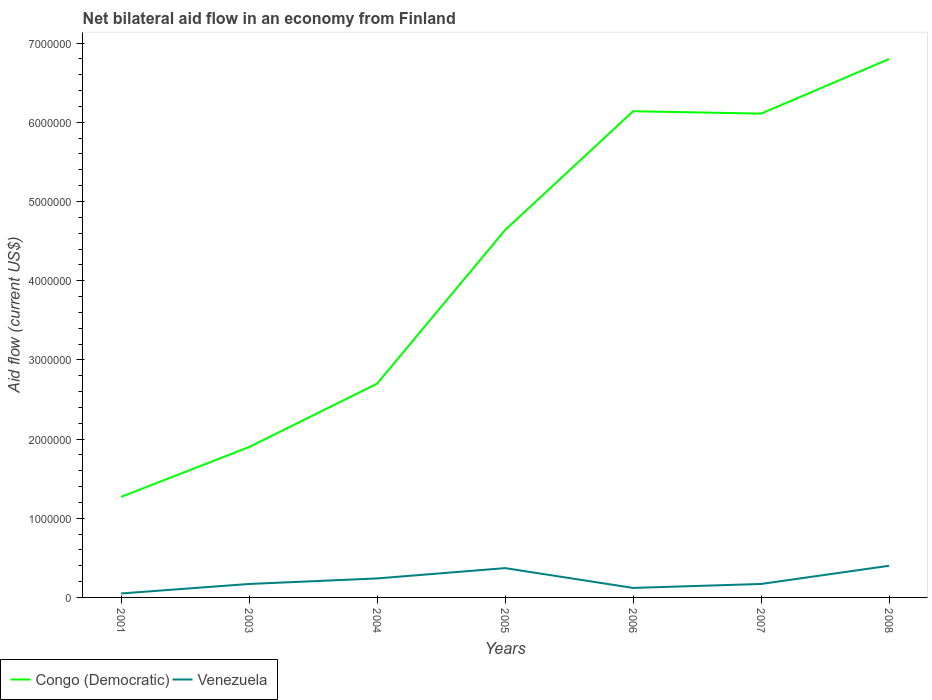Does the line corresponding to Venezuela intersect with the line corresponding to Congo (Democratic)?
Your answer should be compact. No. Across all years, what is the maximum net bilateral aid flow in Congo (Democratic)?
Your answer should be very brief. 1.27e+06. What is the total net bilateral aid flow in Congo (Democratic) in the graph?
Your answer should be compact. -6.90e+05. What is the difference between the highest and the lowest net bilateral aid flow in Congo (Democratic)?
Make the answer very short. 4. Are the values on the major ticks of Y-axis written in scientific E-notation?
Your answer should be compact. No. Does the graph contain grids?
Provide a short and direct response. No. Where does the legend appear in the graph?
Offer a very short reply. Bottom left. How are the legend labels stacked?
Offer a very short reply. Horizontal. What is the title of the graph?
Give a very brief answer. Net bilateral aid flow in an economy from Finland. What is the label or title of the Y-axis?
Offer a terse response. Aid flow (current US$). What is the Aid flow (current US$) in Congo (Democratic) in 2001?
Make the answer very short. 1.27e+06. What is the Aid flow (current US$) in Congo (Democratic) in 2003?
Offer a terse response. 1.90e+06. What is the Aid flow (current US$) in Venezuela in 2003?
Provide a short and direct response. 1.70e+05. What is the Aid flow (current US$) of Congo (Democratic) in 2004?
Your answer should be very brief. 2.70e+06. What is the Aid flow (current US$) in Congo (Democratic) in 2005?
Your response must be concise. 4.64e+06. What is the Aid flow (current US$) of Venezuela in 2005?
Ensure brevity in your answer.  3.70e+05. What is the Aid flow (current US$) in Congo (Democratic) in 2006?
Give a very brief answer. 6.14e+06. What is the Aid flow (current US$) of Venezuela in 2006?
Ensure brevity in your answer.  1.20e+05. What is the Aid flow (current US$) in Congo (Democratic) in 2007?
Give a very brief answer. 6.11e+06. What is the Aid flow (current US$) in Venezuela in 2007?
Give a very brief answer. 1.70e+05. What is the Aid flow (current US$) of Congo (Democratic) in 2008?
Offer a terse response. 6.80e+06. What is the Aid flow (current US$) in Venezuela in 2008?
Give a very brief answer. 4.00e+05. Across all years, what is the maximum Aid flow (current US$) of Congo (Democratic)?
Offer a very short reply. 6.80e+06. Across all years, what is the minimum Aid flow (current US$) in Congo (Democratic)?
Your response must be concise. 1.27e+06. Across all years, what is the minimum Aid flow (current US$) in Venezuela?
Provide a succinct answer. 5.00e+04. What is the total Aid flow (current US$) of Congo (Democratic) in the graph?
Ensure brevity in your answer.  2.96e+07. What is the total Aid flow (current US$) in Venezuela in the graph?
Ensure brevity in your answer.  1.52e+06. What is the difference between the Aid flow (current US$) in Congo (Democratic) in 2001 and that in 2003?
Provide a short and direct response. -6.30e+05. What is the difference between the Aid flow (current US$) of Venezuela in 2001 and that in 2003?
Ensure brevity in your answer.  -1.20e+05. What is the difference between the Aid flow (current US$) in Congo (Democratic) in 2001 and that in 2004?
Provide a succinct answer. -1.43e+06. What is the difference between the Aid flow (current US$) of Venezuela in 2001 and that in 2004?
Offer a terse response. -1.90e+05. What is the difference between the Aid flow (current US$) in Congo (Democratic) in 2001 and that in 2005?
Keep it short and to the point. -3.37e+06. What is the difference between the Aid flow (current US$) of Venezuela in 2001 and that in 2005?
Make the answer very short. -3.20e+05. What is the difference between the Aid flow (current US$) in Congo (Democratic) in 2001 and that in 2006?
Keep it short and to the point. -4.87e+06. What is the difference between the Aid flow (current US$) in Venezuela in 2001 and that in 2006?
Your answer should be compact. -7.00e+04. What is the difference between the Aid flow (current US$) of Congo (Democratic) in 2001 and that in 2007?
Your response must be concise. -4.84e+06. What is the difference between the Aid flow (current US$) of Venezuela in 2001 and that in 2007?
Offer a terse response. -1.20e+05. What is the difference between the Aid flow (current US$) in Congo (Democratic) in 2001 and that in 2008?
Your answer should be compact. -5.53e+06. What is the difference between the Aid flow (current US$) of Venezuela in 2001 and that in 2008?
Ensure brevity in your answer.  -3.50e+05. What is the difference between the Aid flow (current US$) in Congo (Democratic) in 2003 and that in 2004?
Your response must be concise. -8.00e+05. What is the difference between the Aid flow (current US$) in Congo (Democratic) in 2003 and that in 2005?
Your answer should be very brief. -2.74e+06. What is the difference between the Aid flow (current US$) of Venezuela in 2003 and that in 2005?
Your response must be concise. -2.00e+05. What is the difference between the Aid flow (current US$) of Congo (Democratic) in 2003 and that in 2006?
Ensure brevity in your answer.  -4.24e+06. What is the difference between the Aid flow (current US$) of Venezuela in 2003 and that in 2006?
Your answer should be compact. 5.00e+04. What is the difference between the Aid flow (current US$) of Congo (Democratic) in 2003 and that in 2007?
Keep it short and to the point. -4.21e+06. What is the difference between the Aid flow (current US$) in Congo (Democratic) in 2003 and that in 2008?
Provide a short and direct response. -4.90e+06. What is the difference between the Aid flow (current US$) in Venezuela in 2003 and that in 2008?
Make the answer very short. -2.30e+05. What is the difference between the Aid flow (current US$) in Congo (Democratic) in 2004 and that in 2005?
Offer a very short reply. -1.94e+06. What is the difference between the Aid flow (current US$) in Venezuela in 2004 and that in 2005?
Your response must be concise. -1.30e+05. What is the difference between the Aid flow (current US$) of Congo (Democratic) in 2004 and that in 2006?
Keep it short and to the point. -3.44e+06. What is the difference between the Aid flow (current US$) in Venezuela in 2004 and that in 2006?
Make the answer very short. 1.20e+05. What is the difference between the Aid flow (current US$) in Congo (Democratic) in 2004 and that in 2007?
Your response must be concise. -3.41e+06. What is the difference between the Aid flow (current US$) in Venezuela in 2004 and that in 2007?
Your answer should be very brief. 7.00e+04. What is the difference between the Aid flow (current US$) of Congo (Democratic) in 2004 and that in 2008?
Provide a short and direct response. -4.10e+06. What is the difference between the Aid flow (current US$) of Venezuela in 2004 and that in 2008?
Give a very brief answer. -1.60e+05. What is the difference between the Aid flow (current US$) in Congo (Democratic) in 2005 and that in 2006?
Provide a succinct answer. -1.50e+06. What is the difference between the Aid flow (current US$) of Venezuela in 2005 and that in 2006?
Make the answer very short. 2.50e+05. What is the difference between the Aid flow (current US$) in Congo (Democratic) in 2005 and that in 2007?
Provide a succinct answer. -1.47e+06. What is the difference between the Aid flow (current US$) of Congo (Democratic) in 2005 and that in 2008?
Provide a short and direct response. -2.16e+06. What is the difference between the Aid flow (current US$) of Venezuela in 2006 and that in 2007?
Make the answer very short. -5.00e+04. What is the difference between the Aid flow (current US$) of Congo (Democratic) in 2006 and that in 2008?
Provide a succinct answer. -6.60e+05. What is the difference between the Aid flow (current US$) of Venezuela in 2006 and that in 2008?
Keep it short and to the point. -2.80e+05. What is the difference between the Aid flow (current US$) in Congo (Democratic) in 2007 and that in 2008?
Provide a succinct answer. -6.90e+05. What is the difference between the Aid flow (current US$) of Venezuela in 2007 and that in 2008?
Provide a short and direct response. -2.30e+05. What is the difference between the Aid flow (current US$) of Congo (Democratic) in 2001 and the Aid flow (current US$) of Venezuela in 2003?
Your response must be concise. 1.10e+06. What is the difference between the Aid flow (current US$) of Congo (Democratic) in 2001 and the Aid flow (current US$) of Venezuela in 2004?
Offer a terse response. 1.03e+06. What is the difference between the Aid flow (current US$) in Congo (Democratic) in 2001 and the Aid flow (current US$) in Venezuela in 2006?
Your response must be concise. 1.15e+06. What is the difference between the Aid flow (current US$) of Congo (Democratic) in 2001 and the Aid flow (current US$) of Venezuela in 2007?
Keep it short and to the point. 1.10e+06. What is the difference between the Aid flow (current US$) of Congo (Democratic) in 2001 and the Aid flow (current US$) of Venezuela in 2008?
Your answer should be very brief. 8.70e+05. What is the difference between the Aid flow (current US$) of Congo (Democratic) in 2003 and the Aid flow (current US$) of Venezuela in 2004?
Your response must be concise. 1.66e+06. What is the difference between the Aid flow (current US$) of Congo (Democratic) in 2003 and the Aid flow (current US$) of Venezuela in 2005?
Provide a succinct answer. 1.53e+06. What is the difference between the Aid flow (current US$) in Congo (Democratic) in 2003 and the Aid flow (current US$) in Venezuela in 2006?
Offer a very short reply. 1.78e+06. What is the difference between the Aid flow (current US$) of Congo (Democratic) in 2003 and the Aid flow (current US$) of Venezuela in 2007?
Your response must be concise. 1.73e+06. What is the difference between the Aid flow (current US$) in Congo (Democratic) in 2003 and the Aid flow (current US$) in Venezuela in 2008?
Give a very brief answer. 1.50e+06. What is the difference between the Aid flow (current US$) in Congo (Democratic) in 2004 and the Aid flow (current US$) in Venezuela in 2005?
Your response must be concise. 2.33e+06. What is the difference between the Aid flow (current US$) of Congo (Democratic) in 2004 and the Aid flow (current US$) of Venezuela in 2006?
Make the answer very short. 2.58e+06. What is the difference between the Aid flow (current US$) in Congo (Democratic) in 2004 and the Aid flow (current US$) in Venezuela in 2007?
Provide a succinct answer. 2.53e+06. What is the difference between the Aid flow (current US$) in Congo (Democratic) in 2004 and the Aid flow (current US$) in Venezuela in 2008?
Offer a very short reply. 2.30e+06. What is the difference between the Aid flow (current US$) in Congo (Democratic) in 2005 and the Aid flow (current US$) in Venezuela in 2006?
Provide a succinct answer. 4.52e+06. What is the difference between the Aid flow (current US$) in Congo (Democratic) in 2005 and the Aid flow (current US$) in Venezuela in 2007?
Ensure brevity in your answer.  4.47e+06. What is the difference between the Aid flow (current US$) in Congo (Democratic) in 2005 and the Aid flow (current US$) in Venezuela in 2008?
Provide a short and direct response. 4.24e+06. What is the difference between the Aid flow (current US$) in Congo (Democratic) in 2006 and the Aid flow (current US$) in Venezuela in 2007?
Provide a short and direct response. 5.97e+06. What is the difference between the Aid flow (current US$) of Congo (Democratic) in 2006 and the Aid flow (current US$) of Venezuela in 2008?
Give a very brief answer. 5.74e+06. What is the difference between the Aid flow (current US$) in Congo (Democratic) in 2007 and the Aid flow (current US$) in Venezuela in 2008?
Provide a succinct answer. 5.71e+06. What is the average Aid flow (current US$) in Congo (Democratic) per year?
Offer a very short reply. 4.22e+06. What is the average Aid flow (current US$) in Venezuela per year?
Provide a short and direct response. 2.17e+05. In the year 2001, what is the difference between the Aid flow (current US$) of Congo (Democratic) and Aid flow (current US$) of Venezuela?
Keep it short and to the point. 1.22e+06. In the year 2003, what is the difference between the Aid flow (current US$) in Congo (Democratic) and Aid flow (current US$) in Venezuela?
Keep it short and to the point. 1.73e+06. In the year 2004, what is the difference between the Aid flow (current US$) of Congo (Democratic) and Aid flow (current US$) of Venezuela?
Your answer should be very brief. 2.46e+06. In the year 2005, what is the difference between the Aid flow (current US$) of Congo (Democratic) and Aid flow (current US$) of Venezuela?
Your answer should be very brief. 4.27e+06. In the year 2006, what is the difference between the Aid flow (current US$) in Congo (Democratic) and Aid flow (current US$) in Venezuela?
Your answer should be compact. 6.02e+06. In the year 2007, what is the difference between the Aid flow (current US$) of Congo (Democratic) and Aid flow (current US$) of Venezuela?
Your answer should be compact. 5.94e+06. In the year 2008, what is the difference between the Aid flow (current US$) in Congo (Democratic) and Aid flow (current US$) in Venezuela?
Give a very brief answer. 6.40e+06. What is the ratio of the Aid flow (current US$) in Congo (Democratic) in 2001 to that in 2003?
Your response must be concise. 0.67. What is the ratio of the Aid flow (current US$) in Venezuela in 2001 to that in 2003?
Your answer should be very brief. 0.29. What is the ratio of the Aid flow (current US$) of Congo (Democratic) in 2001 to that in 2004?
Give a very brief answer. 0.47. What is the ratio of the Aid flow (current US$) in Venezuela in 2001 to that in 2004?
Ensure brevity in your answer.  0.21. What is the ratio of the Aid flow (current US$) in Congo (Democratic) in 2001 to that in 2005?
Provide a succinct answer. 0.27. What is the ratio of the Aid flow (current US$) in Venezuela in 2001 to that in 2005?
Give a very brief answer. 0.14. What is the ratio of the Aid flow (current US$) in Congo (Democratic) in 2001 to that in 2006?
Your answer should be compact. 0.21. What is the ratio of the Aid flow (current US$) in Venezuela in 2001 to that in 2006?
Your response must be concise. 0.42. What is the ratio of the Aid flow (current US$) of Congo (Democratic) in 2001 to that in 2007?
Offer a terse response. 0.21. What is the ratio of the Aid flow (current US$) in Venezuela in 2001 to that in 2007?
Make the answer very short. 0.29. What is the ratio of the Aid flow (current US$) in Congo (Democratic) in 2001 to that in 2008?
Make the answer very short. 0.19. What is the ratio of the Aid flow (current US$) in Venezuela in 2001 to that in 2008?
Provide a short and direct response. 0.12. What is the ratio of the Aid flow (current US$) in Congo (Democratic) in 2003 to that in 2004?
Offer a terse response. 0.7. What is the ratio of the Aid flow (current US$) of Venezuela in 2003 to that in 2004?
Give a very brief answer. 0.71. What is the ratio of the Aid flow (current US$) of Congo (Democratic) in 2003 to that in 2005?
Keep it short and to the point. 0.41. What is the ratio of the Aid flow (current US$) in Venezuela in 2003 to that in 2005?
Make the answer very short. 0.46. What is the ratio of the Aid flow (current US$) of Congo (Democratic) in 2003 to that in 2006?
Offer a very short reply. 0.31. What is the ratio of the Aid flow (current US$) of Venezuela in 2003 to that in 2006?
Your response must be concise. 1.42. What is the ratio of the Aid flow (current US$) of Congo (Democratic) in 2003 to that in 2007?
Offer a terse response. 0.31. What is the ratio of the Aid flow (current US$) of Venezuela in 2003 to that in 2007?
Your response must be concise. 1. What is the ratio of the Aid flow (current US$) of Congo (Democratic) in 2003 to that in 2008?
Make the answer very short. 0.28. What is the ratio of the Aid flow (current US$) of Venezuela in 2003 to that in 2008?
Keep it short and to the point. 0.42. What is the ratio of the Aid flow (current US$) of Congo (Democratic) in 2004 to that in 2005?
Your answer should be very brief. 0.58. What is the ratio of the Aid flow (current US$) in Venezuela in 2004 to that in 2005?
Offer a very short reply. 0.65. What is the ratio of the Aid flow (current US$) of Congo (Democratic) in 2004 to that in 2006?
Provide a short and direct response. 0.44. What is the ratio of the Aid flow (current US$) of Venezuela in 2004 to that in 2006?
Make the answer very short. 2. What is the ratio of the Aid flow (current US$) in Congo (Democratic) in 2004 to that in 2007?
Provide a succinct answer. 0.44. What is the ratio of the Aid flow (current US$) of Venezuela in 2004 to that in 2007?
Provide a succinct answer. 1.41. What is the ratio of the Aid flow (current US$) in Congo (Democratic) in 2004 to that in 2008?
Offer a very short reply. 0.4. What is the ratio of the Aid flow (current US$) in Venezuela in 2004 to that in 2008?
Give a very brief answer. 0.6. What is the ratio of the Aid flow (current US$) in Congo (Democratic) in 2005 to that in 2006?
Provide a short and direct response. 0.76. What is the ratio of the Aid flow (current US$) in Venezuela in 2005 to that in 2006?
Give a very brief answer. 3.08. What is the ratio of the Aid flow (current US$) in Congo (Democratic) in 2005 to that in 2007?
Keep it short and to the point. 0.76. What is the ratio of the Aid flow (current US$) in Venezuela in 2005 to that in 2007?
Your response must be concise. 2.18. What is the ratio of the Aid flow (current US$) in Congo (Democratic) in 2005 to that in 2008?
Offer a very short reply. 0.68. What is the ratio of the Aid flow (current US$) in Venezuela in 2005 to that in 2008?
Make the answer very short. 0.93. What is the ratio of the Aid flow (current US$) of Congo (Democratic) in 2006 to that in 2007?
Give a very brief answer. 1. What is the ratio of the Aid flow (current US$) in Venezuela in 2006 to that in 2007?
Your answer should be very brief. 0.71. What is the ratio of the Aid flow (current US$) of Congo (Democratic) in 2006 to that in 2008?
Your answer should be very brief. 0.9. What is the ratio of the Aid flow (current US$) in Congo (Democratic) in 2007 to that in 2008?
Your answer should be compact. 0.9. What is the ratio of the Aid flow (current US$) of Venezuela in 2007 to that in 2008?
Provide a succinct answer. 0.42. What is the difference between the highest and the lowest Aid flow (current US$) in Congo (Democratic)?
Your answer should be very brief. 5.53e+06. 